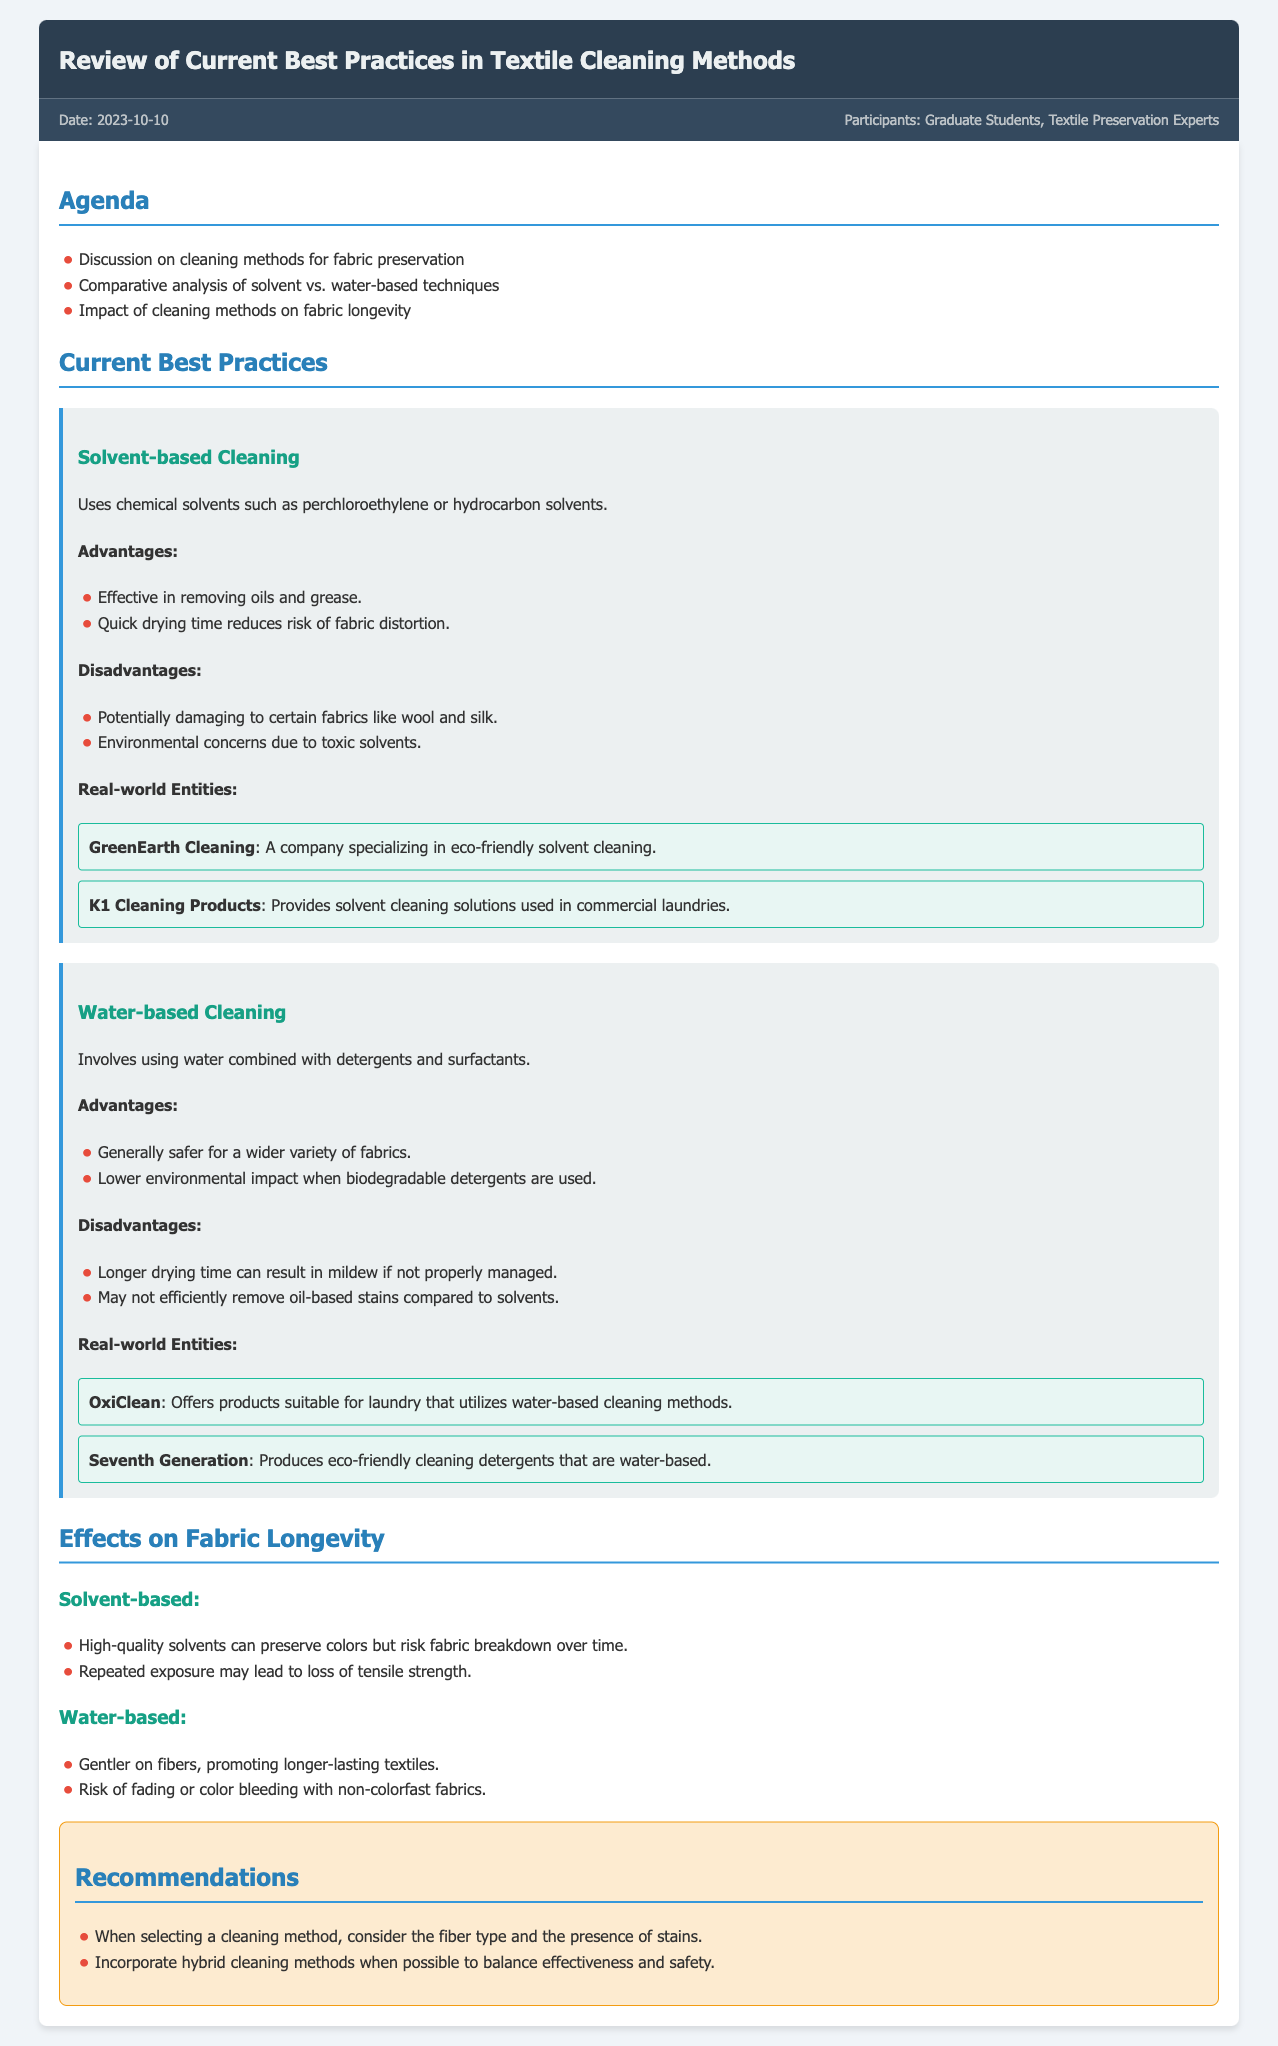What is the date of the meeting? The date of the meeting is mentioned in the meta section of the document.
Answer: 2023-10-10 Who were the participants in the meeting? The participants are listed in the meta section, specifically indicating who attended the meeting.
Answer: Graduate Students, Textile Preservation Experts What is one advantage of solvent-based cleaning? The advantages are detailed in the methods section under solvent-based cleaning.
Answer: Effective in removing oils and grease What is a disadvantage of water-based cleaning? The disadvantages are described in the methods section focusing on water-based cleaning.
Answer: Longer drying time can result in mildew if not properly managed What is a real-world entity associated with solvent-based cleaning? The document provides examples of companies that utilize or produce solvent-based cleaning solutions.
Answer: GreenEarth Cleaning How does solvent-based cleaning affect fabric longevity? The effects of solvent-based cleaning on fabric longevity are outlined in the effects section of the document.
Answer: Risk of fabric breakdown over time What do the recommendations suggest regarding cleaning methods? The recommendations section advises on the selection of cleaning methods based on specific criteria.
Answer: Consider the fiber type and the presence of stains What type of cleaning method is generally safer for fabrics? The document compares the safety of different cleaning methods in the advantages section.
Answer: Water-based cleaning What company produces eco-friendly cleaning detergents? The document lists real-world entities that create environmentally friendly products in the methods section.
Answer: Seventh Generation 